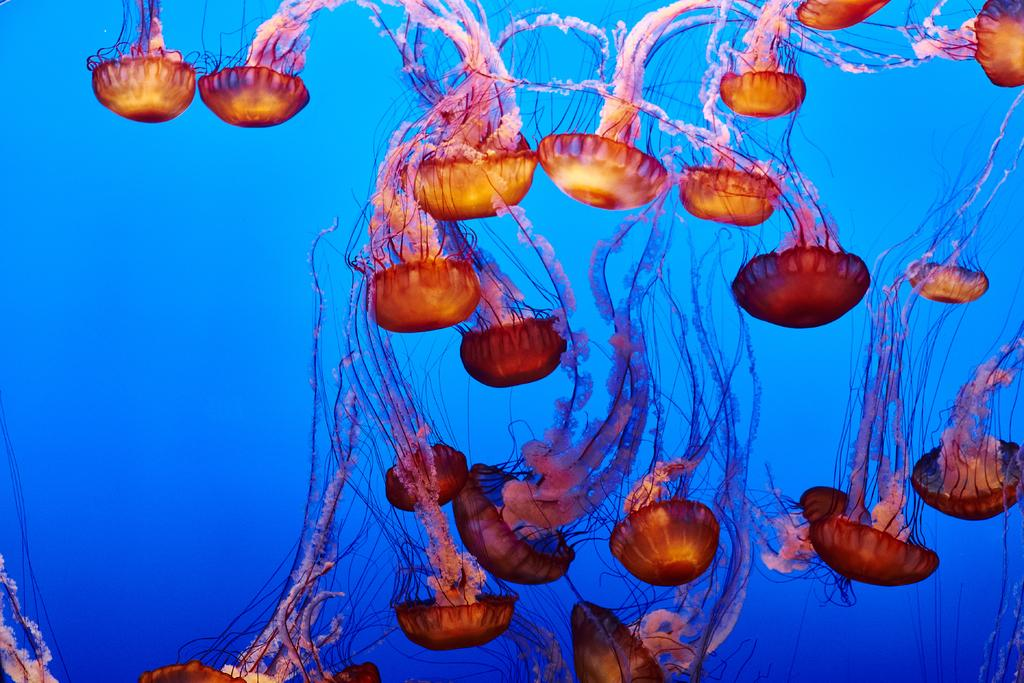What creatures are present in the image? There are jellyfishes in the image. What are the jellyfishes doing in the image? The jellyfishes are moving in the water. What color is the water in the image? The water is blue in color. What type of vegetable can be seen growing in the water in the image? There are no vegetables present in the image; it features jellyfishes moving in blue water. Can you describe the iron content of the water in the image? There is no information about the iron content of the water in the image. 